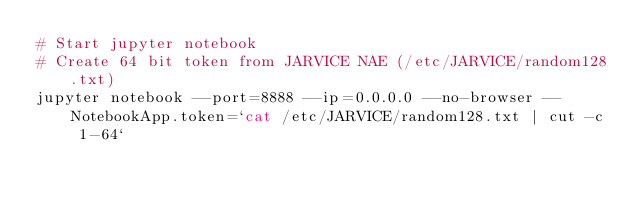<code> <loc_0><loc_0><loc_500><loc_500><_Bash_># Start jupyter notebook
# Create 64 bit token from JARVICE NAE (/etc/JARVICE/random128.txt)
jupyter notebook --port=8888 --ip=0.0.0.0 --no-browser --NotebookApp.token=`cat /etc/JARVICE/random128.txt | cut -c 1-64`
</code> 